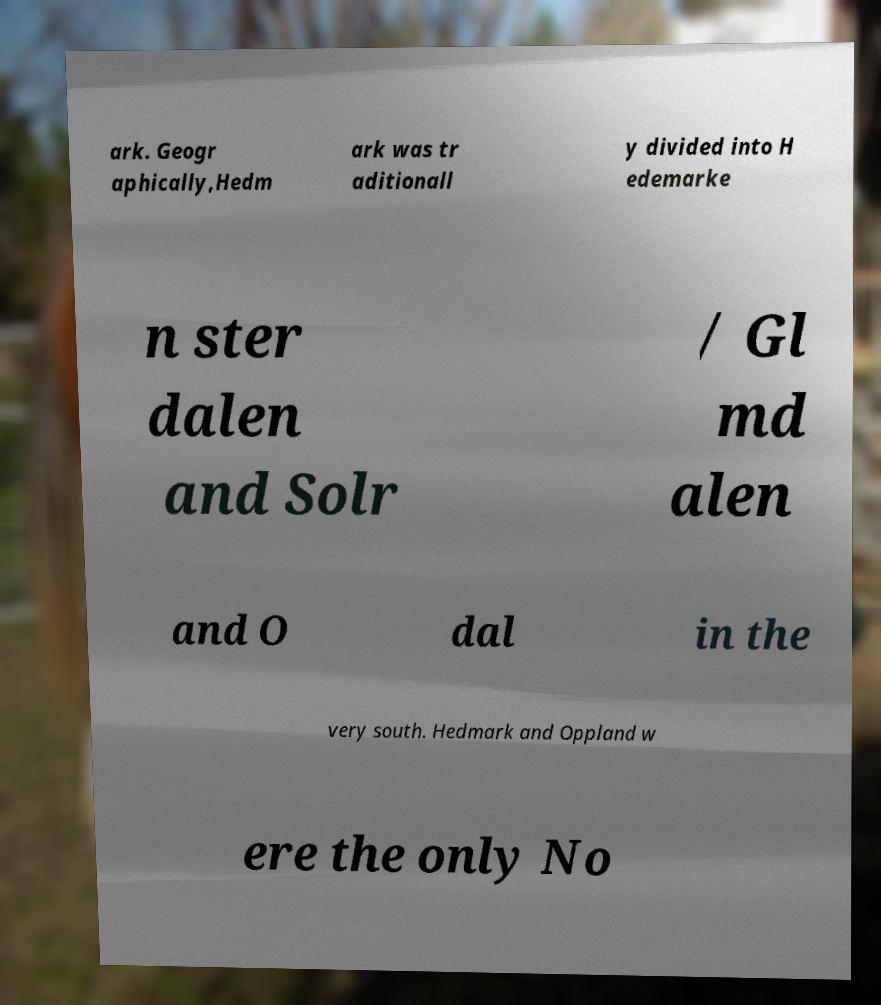I need the written content from this picture converted into text. Can you do that? ark. Geogr aphically,Hedm ark was tr aditionall y divided into H edemarke n ster dalen and Solr / Gl md alen and O dal in the very south. Hedmark and Oppland w ere the only No 